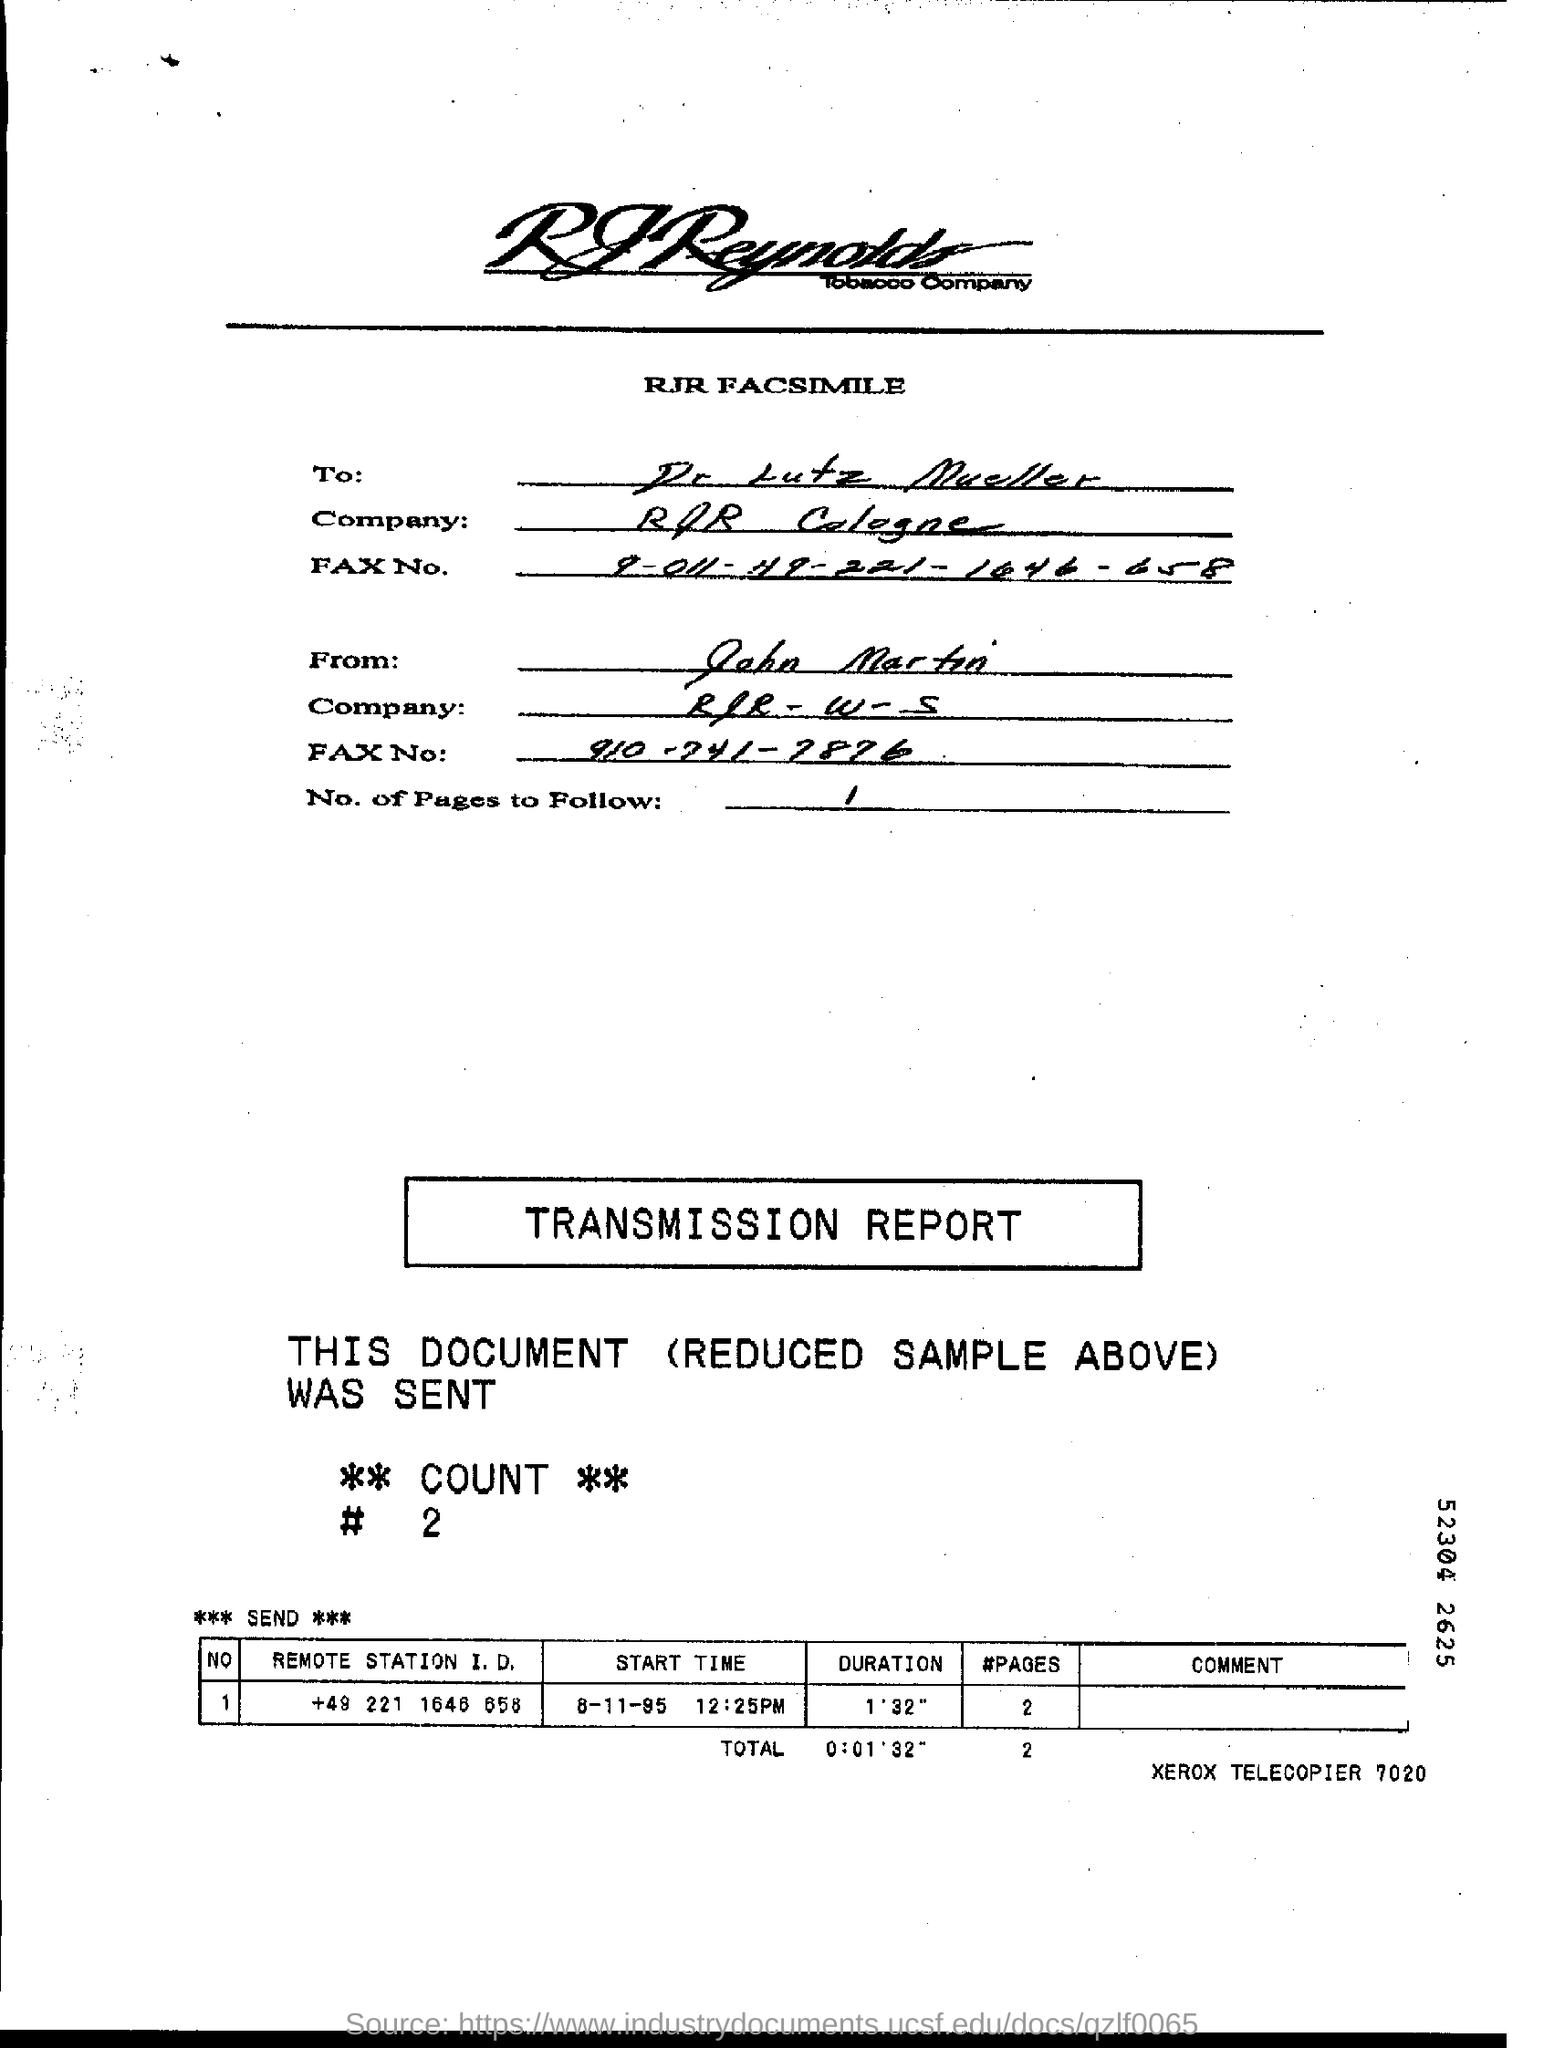Highlight a few significant elements in this photo. The fax is addressed to Dr. Lutz Mueller. The start time for the "Remote station" with the phone number "+49 221 1645 658" is 8-11-95 at 12:25 PM. The fax is from John Martin. 